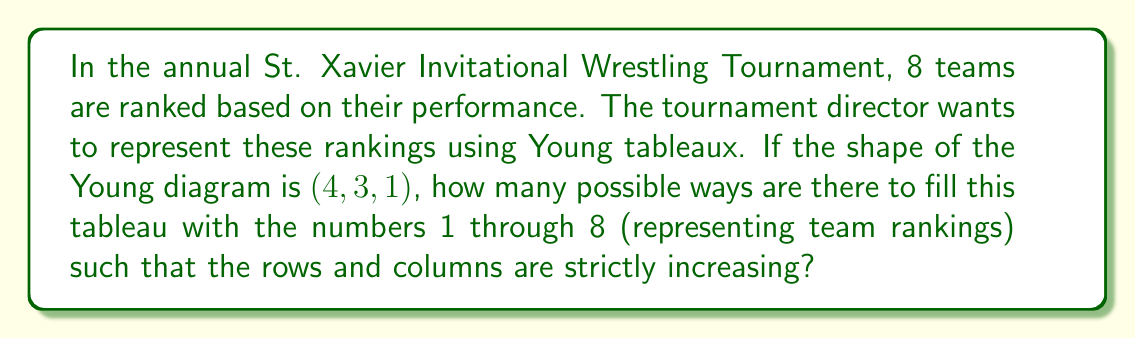Solve this math problem. Let's approach this step-by-step:

1) First, recall that a Young tableau is a way to fill a Young diagram with numbers such that the rows and columns are strictly increasing.

2) The shape $(4,3,1)$ means we have a diagram with 3 rows:
   - First row has 4 boxes
   - Second row has 3 boxes
   - Third row has 1 box

3) We need to fill this diagram with numbers 1 through 8, representing team rankings.

4) Given the strict increasing condition, we know:
   - 1 must be in the top-left corner
   - 8 must be in the bottom-right corner of the first row

5) Now, let's count the number of ways to fill the remaining positions:
   - We have 6 numbers left (2,3,4,5,6,7) and 6 positions to fill

6) For the last position in the first row, we have 3 choices (5,6,7)

7) Once we choose this number, the rest of the tableau is determined because of the increasing condition

8) So, our choices are:
   $$(1,2,3,5), (1,2,3,6), (1,2,3,7)$$ for the first row

9) Each of these determines a unique filling of the entire tableau

10) Therefore, there are 3 possible ways to fill this Young tableau
Answer: 3 